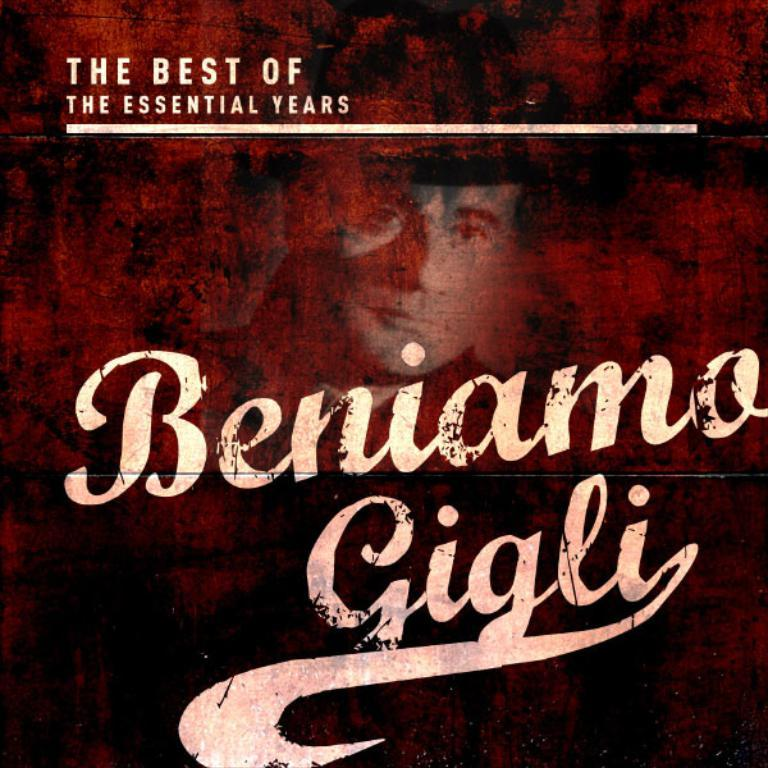<image>
Write a terse but informative summary of the picture. a cover for Beniamo Gigli The Best of The Essential Years 